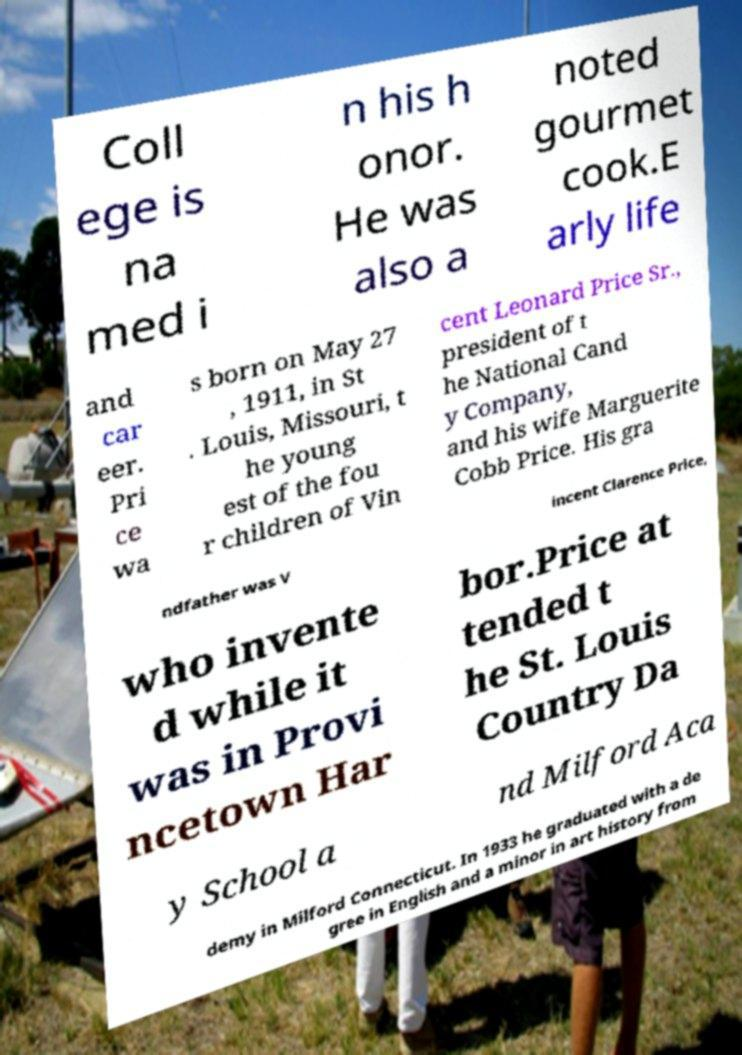Can you read and provide the text displayed in the image?This photo seems to have some interesting text. Can you extract and type it out for me? Coll ege is na med i n his h onor. He was also a noted gourmet cook.E arly life and car eer. Pri ce wa s born on May 27 , 1911, in St . Louis, Missouri, t he young est of the fou r children of Vin cent Leonard Price Sr., president of t he National Cand y Company, and his wife Marguerite Cobb Price. His gra ndfather was V incent Clarence Price, who invente d while it was in Provi ncetown Har bor.Price at tended t he St. Louis Country Da y School a nd Milford Aca demy in Milford Connecticut. In 1933 he graduated with a de gree in English and a minor in art history from 